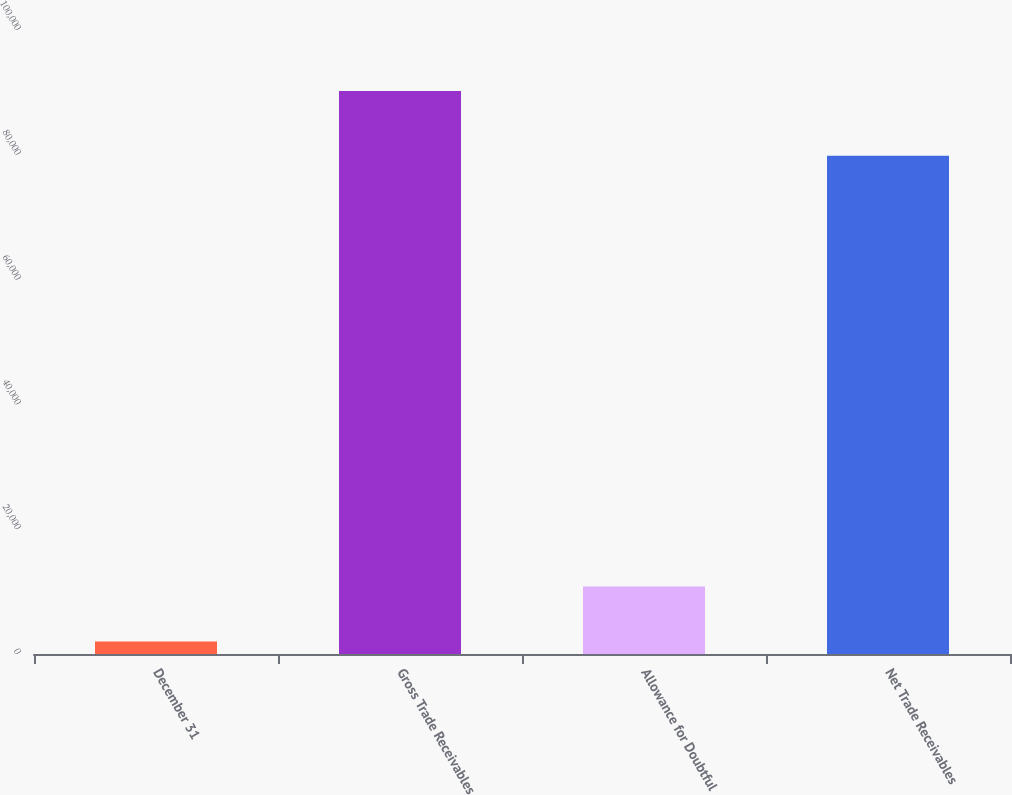<chart> <loc_0><loc_0><loc_500><loc_500><bar_chart><fcel>December 31<fcel>Gross Trade Receivables<fcel>Allowance for Doubtful<fcel>Net Trade Receivables<nl><fcel>2015<fcel>90212<fcel>10834.7<fcel>79864<nl></chart> 